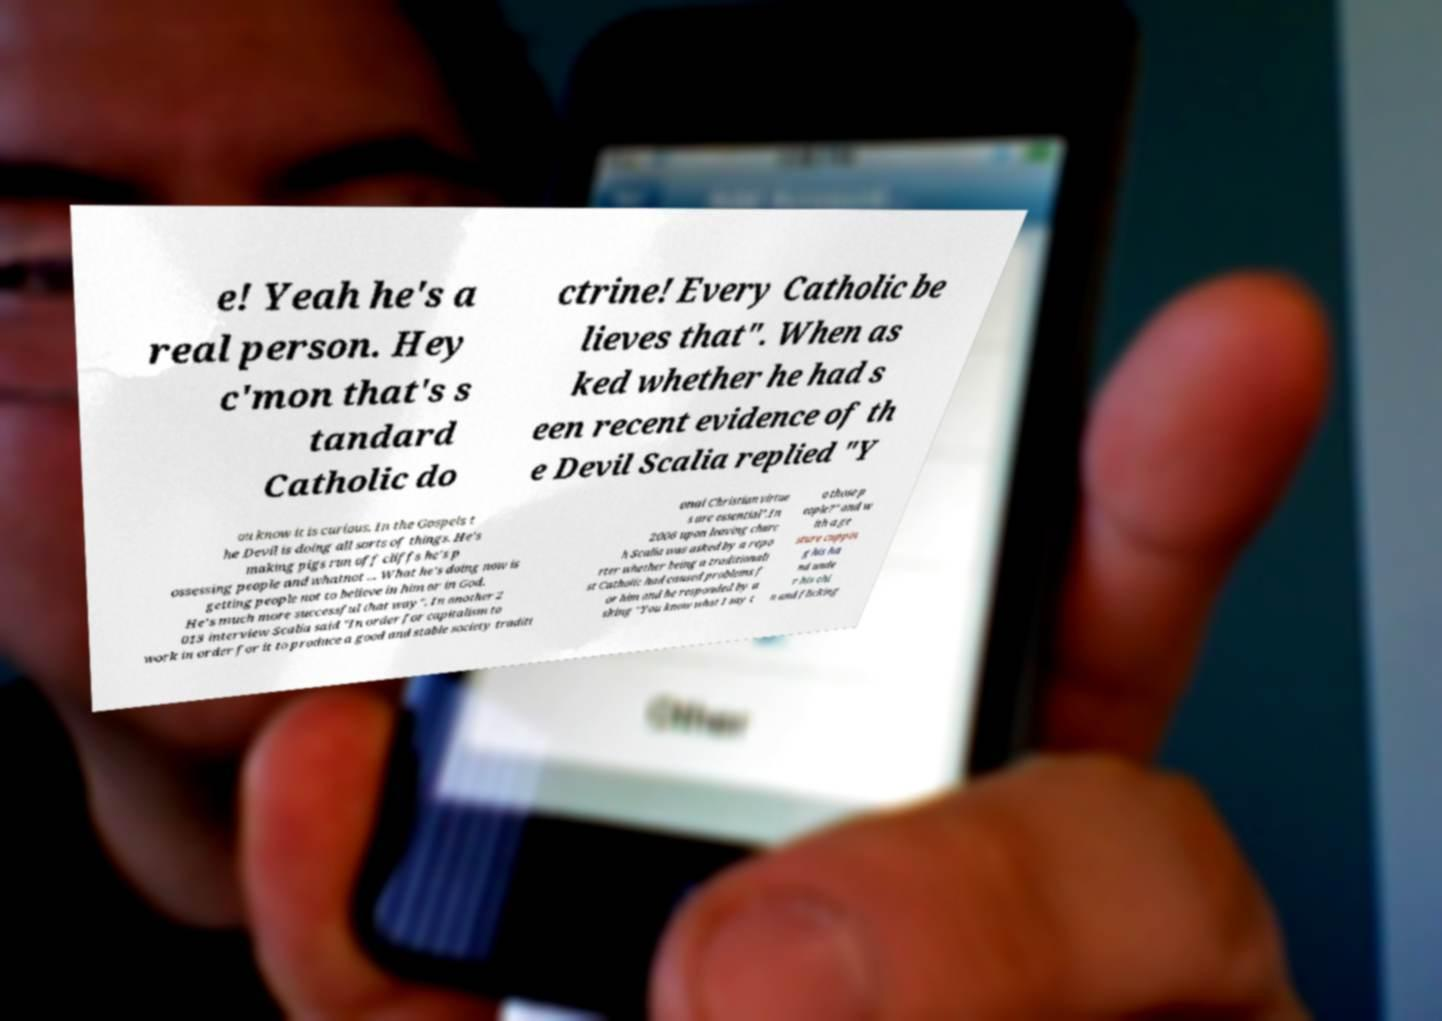Please read and relay the text visible in this image. What does it say? e! Yeah he's a real person. Hey c'mon that's s tandard Catholic do ctrine! Every Catholic be lieves that". When as ked whether he had s een recent evidence of th e Devil Scalia replied "Y ou know it is curious. In the Gospels t he Devil is doing all sorts of things. He's making pigs run off cliffs he's p ossessing people and whatnot ... What he's doing now is getting people not to believe in him or in God. He's much more successful that way". In another 2 013 interview Scalia said "In order for capitalism to work in order for it to produce a good and stable society traditi onal Christian virtue s are essential".In 2006 upon leaving churc h Scalia was asked by a repo rter whether being a traditionali st Catholic had caused problems f or him and he responded by a sking "You know what I say t o those p eople?" and w ith a ge sture cuppin g his ha nd unde r his chi n and flicking 